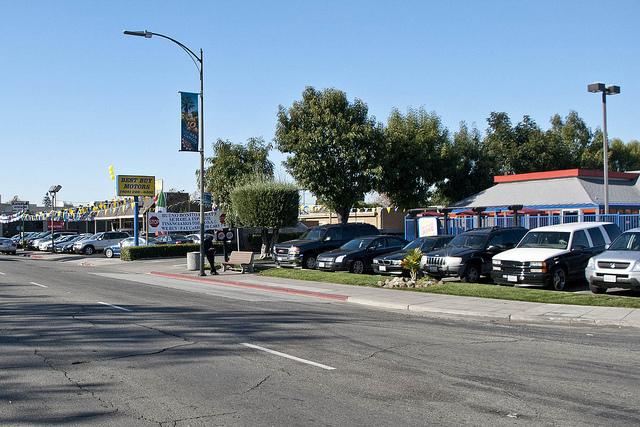Is it a cloudy day?
Write a very short answer. No. What color is the fence?
Give a very brief answer. Blue. How many cars are in the picture?
Keep it brief. 15. Is it a good day for a picnic?
Concise answer only. Yes. How is traffic?
Give a very brief answer. Good. Is it a sunny day?
Quick response, please. Yes. What is the name of the oil change business advertised in the photo?
Give a very brief answer. Best buy motors. Is the street crowded?
Write a very short answer. No. 